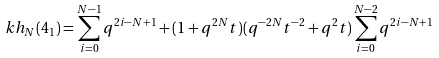<formula> <loc_0><loc_0><loc_500><loc_500>\ k h _ { N } ( 4 _ { 1 } ) = \sum _ { i = 0 } ^ { N - 1 } q ^ { 2 i - N + 1 } + ( 1 + q ^ { 2 N } t ) ( q ^ { - 2 N } t ^ { - 2 } + q ^ { 2 } t ) \sum _ { i = 0 } ^ { N - 2 } q ^ { 2 i - N + 1 }</formula> 